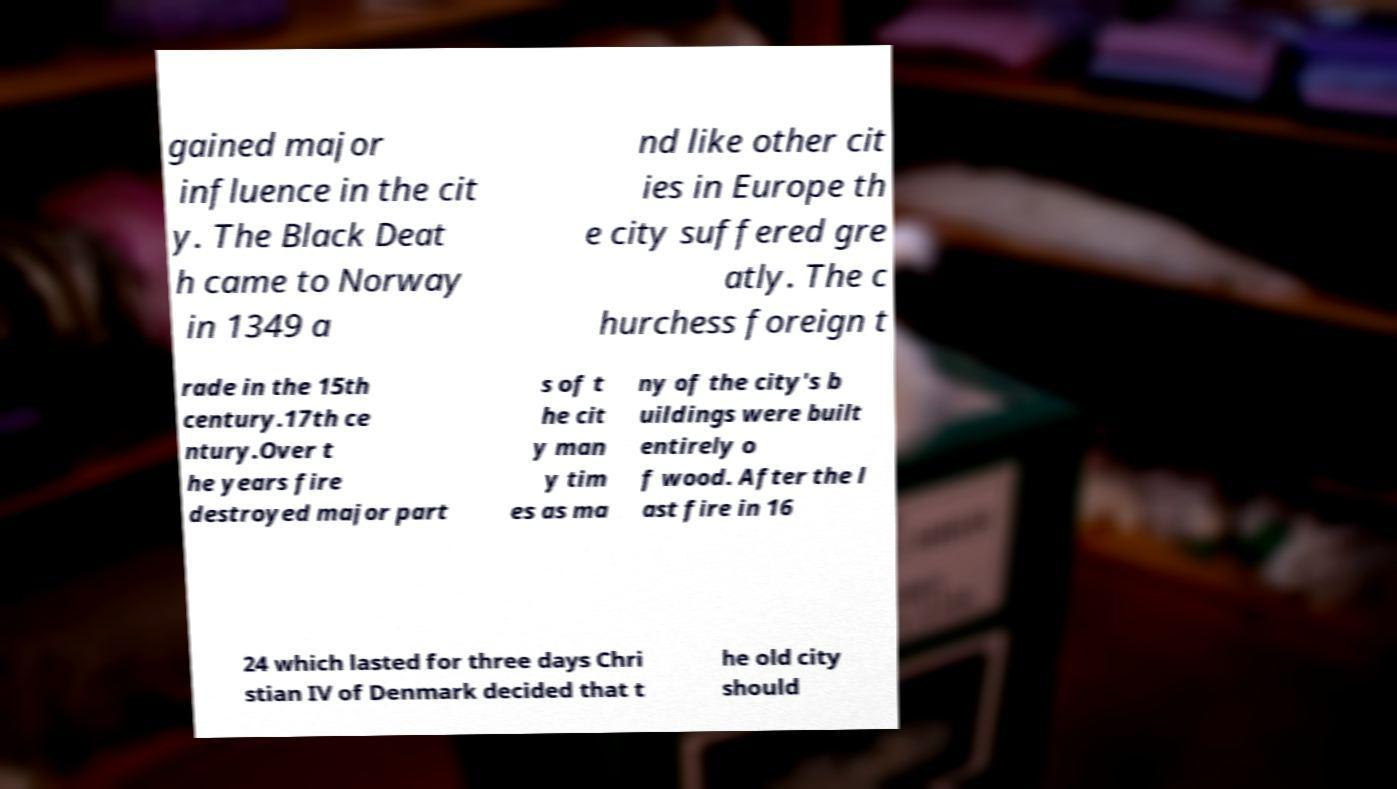What messages or text are displayed in this image? I need them in a readable, typed format. gained major influence in the cit y. The Black Deat h came to Norway in 1349 a nd like other cit ies in Europe th e city suffered gre atly. The c hurchess foreign t rade in the 15th century.17th ce ntury.Over t he years fire destroyed major part s of t he cit y man y tim es as ma ny of the city's b uildings were built entirely o f wood. After the l ast fire in 16 24 which lasted for three days Chri stian IV of Denmark decided that t he old city should 